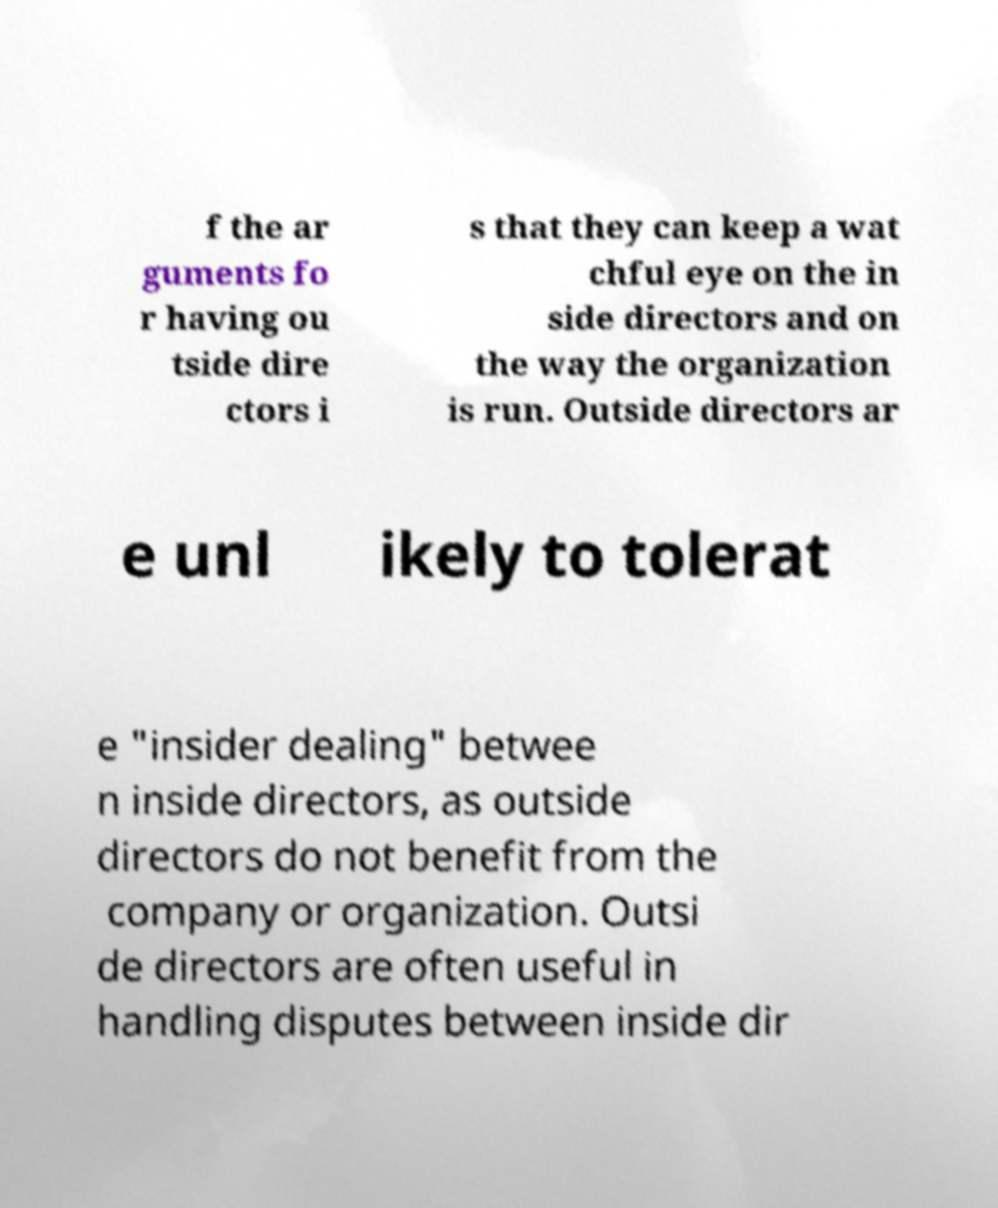For documentation purposes, I need the text within this image transcribed. Could you provide that? f the ar guments fo r having ou tside dire ctors i s that they can keep a wat chful eye on the in side directors and on the way the organization is run. Outside directors ar e unl ikely to tolerat e "insider dealing" betwee n inside directors, as outside directors do not benefit from the company or organization. Outsi de directors are often useful in handling disputes between inside dir 